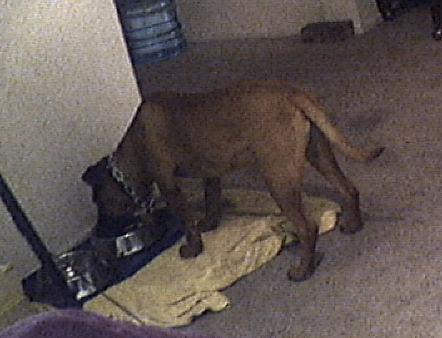What breed of dog is it?
Answer briefly. Pitbull. Are the bowls plastic or metal?
Short answer required. Metal. What is the container likely made of?
Write a very short answer. Metal. Is the dog eating?
Concise answer only. Yes. How many dogs can be seen?
Keep it brief. 1. What is the main color of the dog?
Short answer required. Brown. 